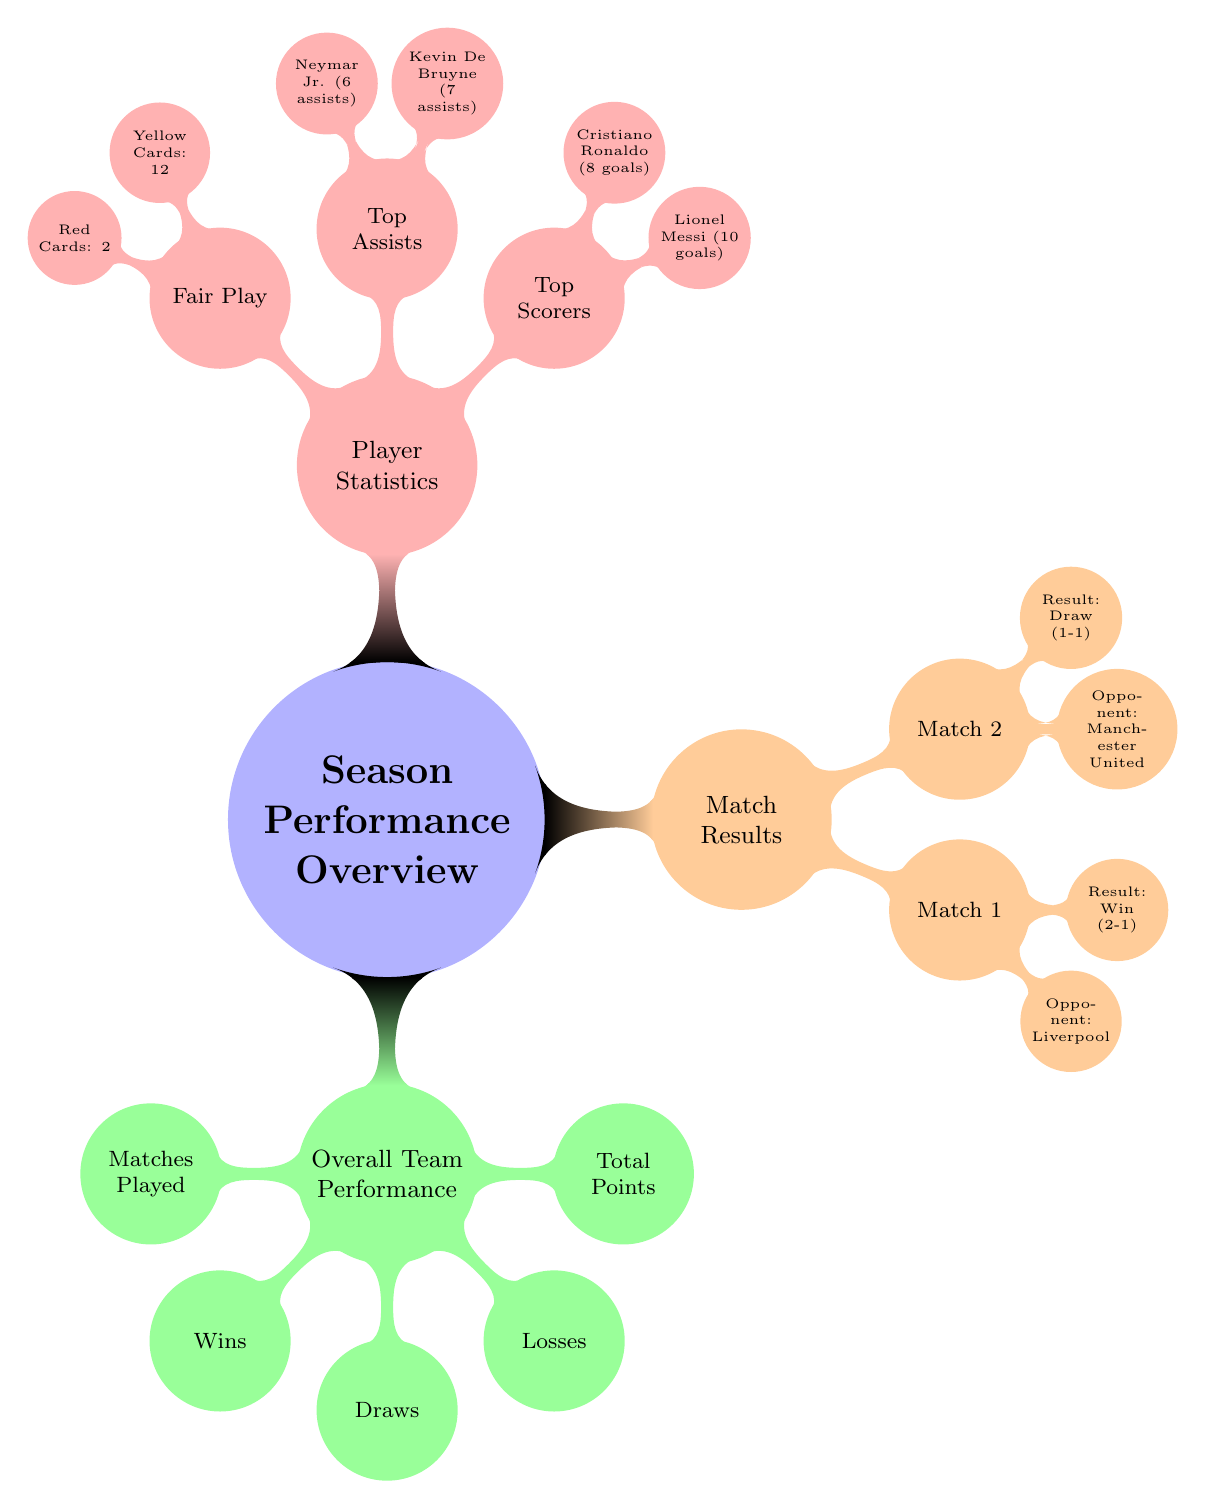What's the total number of matches played? The diagram indicates that matches played are a sub-node under Overall Team Performance. However, the exact number of matches is not provided in the diagram. Therefore, it cannot be determined from the current information listed.
Answer: Not specified How many wins did the team have? The wins node under Overall Team Performance directly states the value associated with wins, which can be found in the subtree of Overall Team Performance. However, the value itself is not provided in the diagram.
Answer: Not specified What is the result of Match 1? Match 1 is listed with its details under the Match Results section. By examining the node, it is clear that the result of Match 1 is a Win (2-1).
Answer: Win (2-1) Who is the top scorer? The top scorers are indicated as child nodes under Player Statistics. Among them, Lionel Messi is mentioned first with the total goals scored clearly specified as 10 goals.
Answer: Lionel Messi (10 goals) How many red cards were issued? The Fair Play section under Player Statistics provides specific details related to disciplinary actions. The node for red cards clearly indicates the number of red cards issued, which is 2.
Answer: 2 What was the result of the match against Manchester United? Referring to the Match Results section, the details under Match 2 specifically state that the result against Manchester United was a Draw (1-1).
Answer: Draw (1-1) How many assists did Kevin De Bruyne have? The Player Statistics section outlines the statistics for top assists. Kevin De Bruyne is mentioned as a top assister with 7 assists directly stated in the diagram.
Answer: 7 assists What is the total number of yellow cards? The Fair Play section of Player Statistics specifically lists the number of yellow cards issued as 12. This value is explicitly provided in the diagram.
Answer: 12 How many matches resulted in a draw? The diagram includes the draws as a category under Overall Team Performance. However, without a specific numeric value provided next to draws, the total count cannot be derived directly from the information shown.
Answer: Not specified 